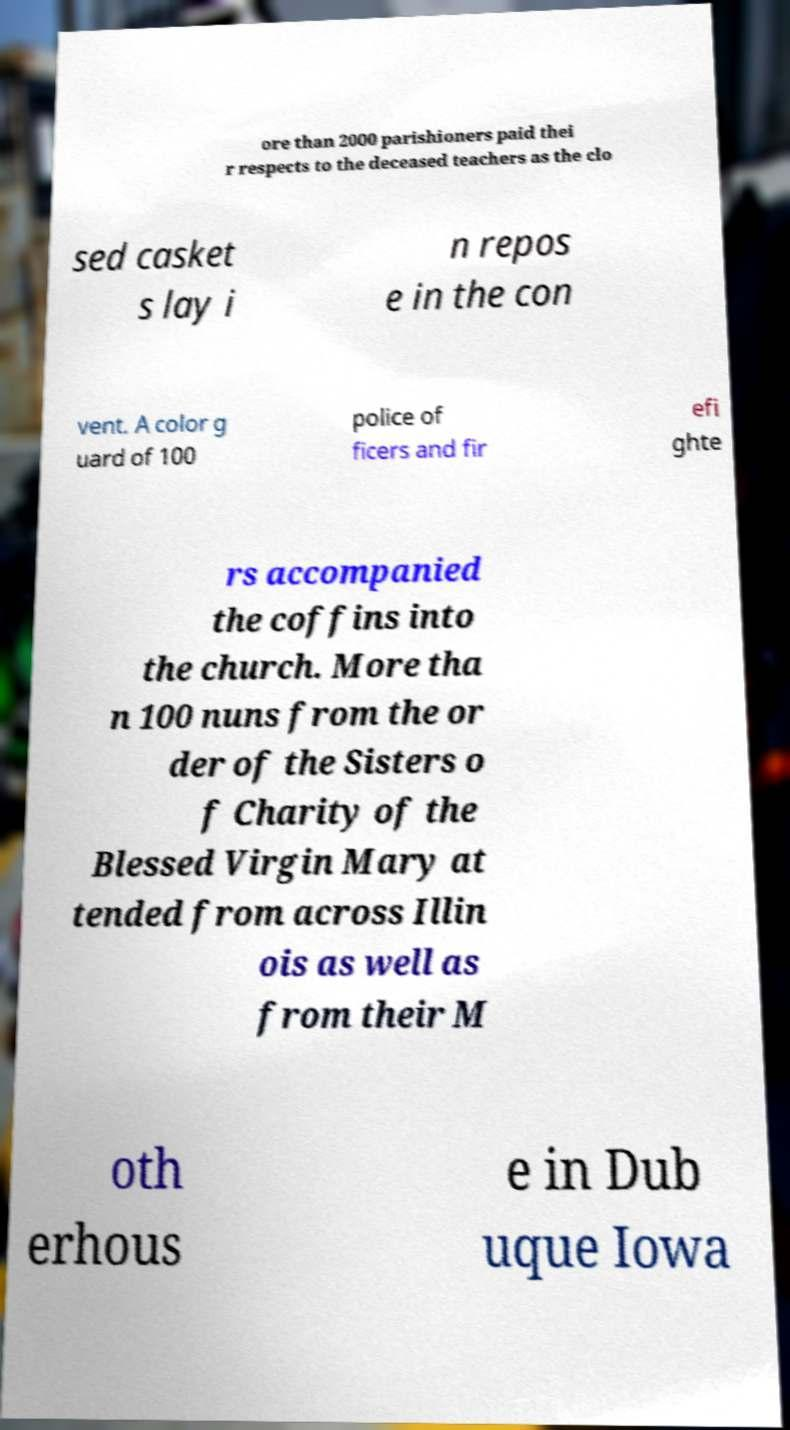Please read and relay the text visible in this image. What does it say? ore than 2000 parishioners paid thei r respects to the deceased teachers as the clo sed casket s lay i n repos e in the con vent. A color g uard of 100 police of ficers and fir efi ghte rs accompanied the coffins into the church. More tha n 100 nuns from the or der of the Sisters o f Charity of the Blessed Virgin Mary at tended from across Illin ois as well as from their M oth erhous e in Dub uque Iowa 